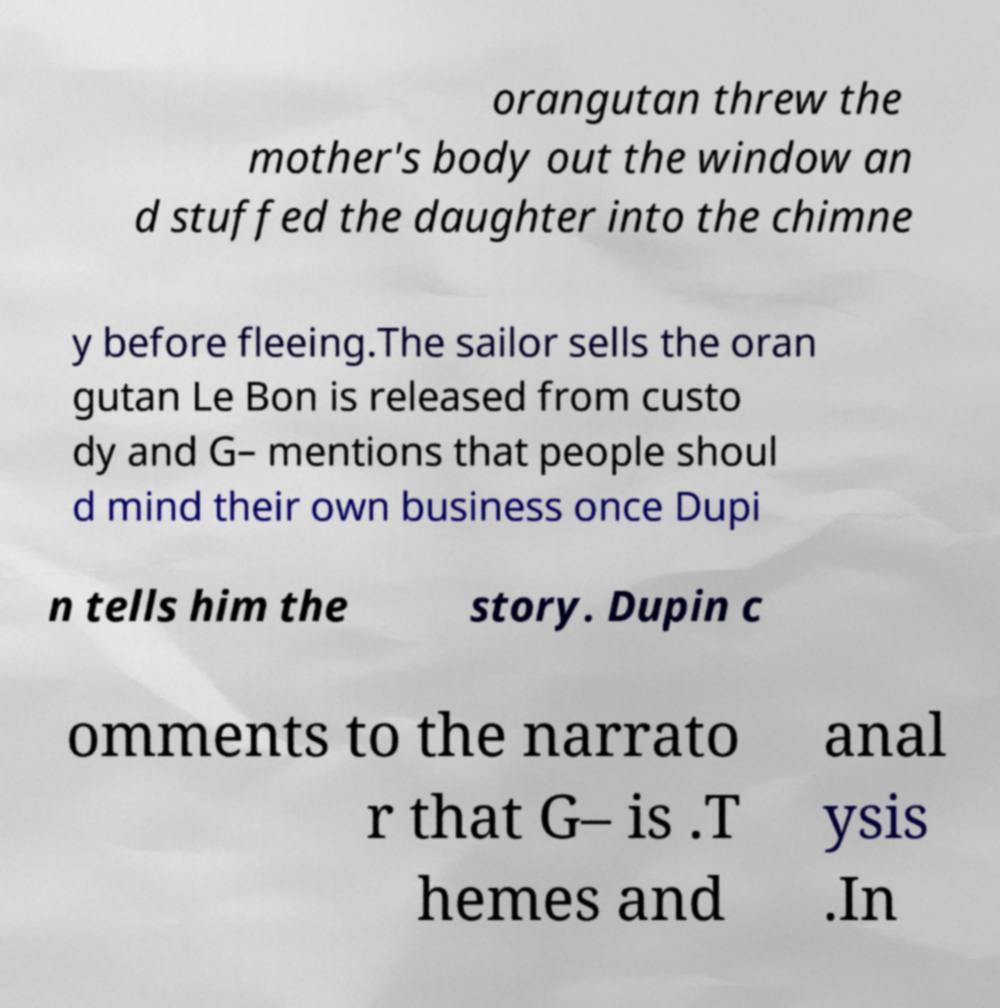For documentation purposes, I need the text within this image transcribed. Could you provide that? orangutan threw the mother's body out the window an d stuffed the daughter into the chimne y before fleeing.The sailor sells the oran gutan Le Bon is released from custo dy and G– mentions that people shoul d mind their own business once Dupi n tells him the story. Dupin c omments to the narrato r that G– is .T hemes and anal ysis .In 